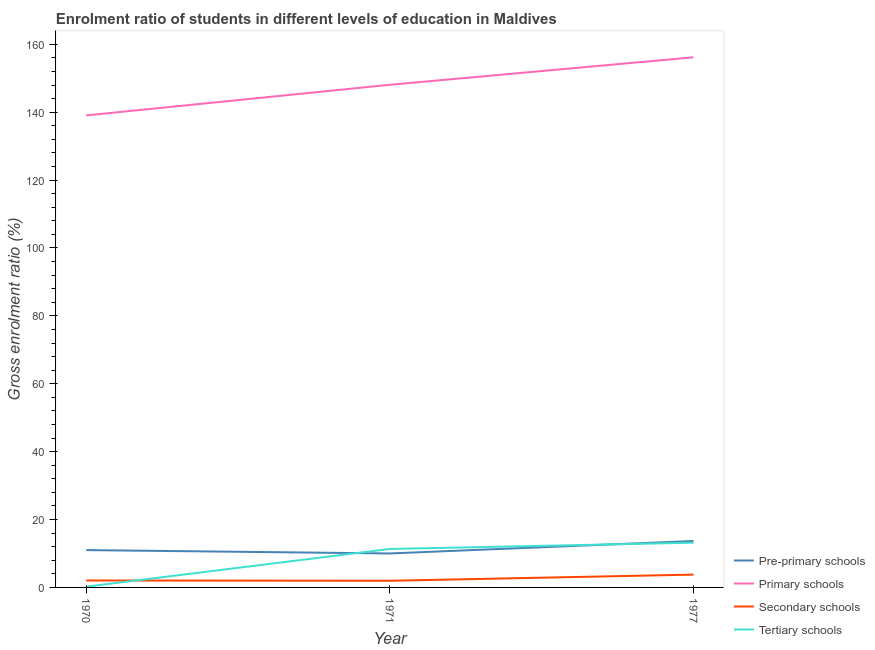Does the line corresponding to gross enrolment ratio in tertiary schools intersect with the line corresponding to gross enrolment ratio in primary schools?
Give a very brief answer. No. What is the gross enrolment ratio in pre-primary schools in 1977?
Your answer should be compact. 13.67. Across all years, what is the maximum gross enrolment ratio in secondary schools?
Offer a terse response. 3.78. Across all years, what is the minimum gross enrolment ratio in secondary schools?
Keep it short and to the point. 1.96. In which year was the gross enrolment ratio in tertiary schools minimum?
Offer a terse response. 1970. What is the total gross enrolment ratio in secondary schools in the graph?
Offer a terse response. 7.78. What is the difference between the gross enrolment ratio in tertiary schools in 1971 and that in 1977?
Give a very brief answer. -1.85. What is the difference between the gross enrolment ratio in secondary schools in 1971 and the gross enrolment ratio in pre-primary schools in 1970?
Make the answer very short. -9.04. What is the average gross enrolment ratio in tertiary schools per year?
Offer a terse response. 8.25. In the year 1970, what is the difference between the gross enrolment ratio in pre-primary schools and gross enrolment ratio in tertiary schools?
Give a very brief answer. 10.78. What is the ratio of the gross enrolment ratio in primary schools in 1971 to that in 1977?
Your answer should be compact. 0.95. Is the gross enrolment ratio in pre-primary schools in 1970 less than that in 1971?
Provide a succinct answer. No. Is the difference between the gross enrolment ratio in primary schools in 1970 and 1977 greater than the difference between the gross enrolment ratio in pre-primary schools in 1970 and 1977?
Your answer should be compact. No. What is the difference between the highest and the second highest gross enrolment ratio in tertiary schools?
Give a very brief answer. 1.85. What is the difference between the highest and the lowest gross enrolment ratio in primary schools?
Keep it short and to the point. 17.12. Is the sum of the gross enrolment ratio in secondary schools in 1970 and 1977 greater than the maximum gross enrolment ratio in pre-primary schools across all years?
Your response must be concise. No. Is it the case that in every year, the sum of the gross enrolment ratio in pre-primary schools and gross enrolment ratio in primary schools is greater than the gross enrolment ratio in secondary schools?
Your answer should be very brief. Yes. Does the gross enrolment ratio in pre-primary schools monotonically increase over the years?
Your response must be concise. No. Is the gross enrolment ratio in secondary schools strictly less than the gross enrolment ratio in tertiary schools over the years?
Ensure brevity in your answer.  No. How many lines are there?
Provide a succinct answer. 4. How many legend labels are there?
Make the answer very short. 4. How are the legend labels stacked?
Your answer should be very brief. Vertical. What is the title of the graph?
Keep it short and to the point. Enrolment ratio of students in different levels of education in Maldives. What is the Gross enrolment ratio (%) of Pre-primary schools in 1970?
Keep it short and to the point. 11. What is the Gross enrolment ratio (%) in Primary schools in 1970?
Your response must be concise. 139.05. What is the Gross enrolment ratio (%) of Secondary schools in 1970?
Keep it short and to the point. 2.05. What is the Gross enrolment ratio (%) of Tertiary schools in 1970?
Make the answer very short. 0.22. What is the Gross enrolment ratio (%) in Pre-primary schools in 1971?
Keep it short and to the point. 10.01. What is the Gross enrolment ratio (%) in Primary schools in 1971?
Your response must be concise. 148.08. What is the Gross enrolment ratio (%) in Secondary schools in 1971?
Give a very brief answer. 1.96. What is the Gross enrolment ratio (%) in Tertiary schools in 1971?
Make the answer very short. 11.34. What is the Gross enrolment ratio (%) in Pre-primary schools in 1977?
Ensure brevity in your answer.  13.67. What is the Gross enrolment ratio (%) in Primary schools in 1977?
Your answer should be compact. 156.17. What is the Gross enrolment ratio (%) of Secondary schools in 1977?
Your answer should be compact. 3.78. What is the Gross enrolment ratio (%) of Tertiary schools in 1977?
Your response must be concise. 13.18. Across all years, what is the maximum Gross enrolment ratio (%) in Pre-primary schools?
Provide a short and direct response. 13.67. Across all years, what is the maximum Gross enrolment ratio (%) in Primary schools?
Your answer should be compact. 156.17. Across all years, what is the maximum Gross enrolment ratio (%) in Secondary schools?
Provide a short and direct response. 3.78. Across all years, what is the maximum Gross enrolment ratio (%) of Tertiary schools?
Provide a succinct answer. 13.18. Across all years, what is the minimum Gross enrolment ratio (%) of Pre-primary schools?
Ensure brevity in your answer.  10.01. Across all years, what is the minimum Gross enrolment ratio (%) of Primary schools?
Offer a very short reply. 139.05. Across all years, what is the minimum Gross enrolment ratio (%) of Secondary schools?
Provide a succinct answer. 1.96. Across all years, what is the minimum Gross enrolment ratio (%) of Tertiary schools?
Provide a short and direct response. 0.22. What is the total Gross enrolment ratio (%) in Pre-primary schools in the graph?
Make the answer very short. 34.68. What is the total Gross enrolment ratio (%) of Primary schools in the graph?
Provide a succinct answer. 443.3. What is the total Gross enrolment ratio (%) in Secondary schools in the graph?
Ensure brevity in your answer.  7.78. What is the total Gross enrolment ratio (%) in Tertiary schools in the graph?
Keep it short and to the point. 24.74. What is the difference between the Gross enrolment ratio (%) of Pre-primary schools in 1970 and that in 1971?
Your answer should be compact. 0.99. What is the difference between the Gross enrolment ratio (%) of Primary schools in 1970 and that in 1971?
Give a very brief answer. -9.02. What is the difference between the Gross enrolment ratio (%) of Secondary schools in 1970 and that in 1971?
Give a very brief answer. 0.09. What is the difference between the Gross enrolment ratio (%) of Tertiary schools in 1970 and that in 1971?
Give a very brief answer. -11.11. What is the difference between the Gross enrolment ratio (%) in Pre-primary schools in 1970 and that in 1977?
Offer a terse response. -2.67. What is the difference between the Gross enrolment ratio (%) in Primary schools in 1970 and that in 1977?
Your response must be concise. -17.12. What is the difference between the Gross enrolment ratio (%) in Secondary schools in 1970 and that in 1977?
Give a very brief answer. -1.73. What is the difference between the Gross enrolment ratio (%) in Tertiary schools in 1970 and that in 1977?
Give a very brief answer. -12.96. What is the difference between the Gross enrolment ratio (%) of Pre-primary schools in 1971 and that in 1977?
Provide a short and direct response. -3.67. What is the difference between the Gross enrolment ratio (%) of Primary schools in 1971 and that in 1977?
Provide a short and direct response. -8.09. What is the difference between the Gross enrolment ratio (%) of Secondary schools in 1971 and that in 1977?
Ensure brevity in your answer.  -1.81. What is the difference between the Gross enrolment ratio (%) of Tertiary schools in 1971 and that in 1977?
Offer a terse response. -1.85. What is the difference between the Gross enrolment ratio (%) in Pre-primary schools in 1970 and the Gross enrolment ratio (%) in Primary schools in 1971?
Offer a terse response. -137.08. What is the difference between the Gross enrolment ratio (%) in Pre-primary schools in 1970 and the Gross enrolment ratio (%) in Secondary schools in 1971?
Keep it short and to the point. 9.04. What is the difference between the Gross enrolment ratio (%) of Pre-primary schools in 1970 and the Gross enrolment ratio (%) of Tertiary schools in 1971?
Keep it short and to the point. -0.34. What is the difference between the Gross enrolment ratio (%) of Primary schools in 1970 and the Gross enrolment ratio (%) of Secondary schools in 1971?
Make the answer very short. 137.09. What is the difference between the Gross enrolment ratio (%) of Primary schools in 1970 and the Gross enrolment ratio (%) of Tertiary schools in 1971?
Your answer should be very brief. 127.72. What is the difference between the Gross enrolment ratio (%) of Secondary schools in 1970 and the Gross enrolment ratio (%) of Tertiary schools in 1971?
Your response must be concise. -9.29. What is the difference between the Gross enrolment ratio (%) of Pre-primary schools in 1970 and the Gross enrolment ratio (%) of Primary schools in 1977?
Give a very brief answer. -145.17. What is the difference between the Gross enrolment ratio (%) of Pre-primary schools in 1970 and the Gross enrolment ratio (%) of Secondary schools in 1977?
Your answer should be very brief. 7.22. What is the difference between the Gross enrolment ratio (%) of Pre-primary schools in 1970 and the Gross enrolment ratio (%) of Tertiary schools in 1977?
Offer a very short reply. -2.18. What is the difference between the Gross enrolment ratio (%) in Primary schools in 1970 and the Gross enrolment ratio (%) in Secondary schools in 1977?
Make the answer very short. 135.28. What is the difference between the Gross enrolment ratio (%) of Primary schools in 1970 and the Gross enrolment ratio (%) of Tertiary schools in 1977?
Provide a succinct answer. 125.87. What is the difference between the Gross enrolment ratio (%) of Secondary schools in 1970 and the Gross enrolment ratio (%) of Tertiary schools in 1977?
Provide a succinct answer. -11.13. What is the difference between the Gross enrolment ratio (%) of Pre-primary schools in 1971 and the Gross enrolment ratio (%) of Primary schools in 1977?
Provide a succinct answer. -146.16. What is the difference between the Gross enrolment ratio (%) of Pre-primary schools in 1971 and the Gross enrolment ratio (%) of Secondary schools in 1977?
Your response must be concise. 6.23. What is the difference between the Gross enrolment ratio (%) in Pre-primary schools in 1971 and the Gross enrolment ratio (%) in Tertiary schools in 1977?
Your answer should be compact. -3.17. What is the difference between the Gross enrolment ratio (%) of Primary schools in 1971 and the Gross enrolment ratio (%) of Secondary schools in 1977?
Offer a terse response. 144.3. What is the difference between the Gross enrolment ratio (%) of Primary schools in 1971 and the Gross enrolment ratio (%) of Tertiary schools in 1977?
Offer a terse response. 134.89. What is the difference between the Gross enrolment ratio (%) of Secondary schools in 1971 and the Gross enrolment ratio (%) of Tertiary schools in 1977?
Offer a very short reply. -11.22. What is the average Gross enrolment ratio (%) of Pre-primary schools per year?
Give a very brief answer. 11.56. What is the average Gross enrolment ratio (%) in Primary schools per year?
Your answer should be very brief. 147.77. What is the average Gross enrolment ratio (%) of Secondary schools per year?
Provide a succinct answer. 2.59. What is the average Gross enrolment ratio (%) in Tertiary schools per year?
Provide a succinct answer. 8.25. In the year 1970, what is the difference between the Gross enrolment ratio (%) of Pre-primary schools and Gross enrolment ratio (%) of Primary schools?
Your answer should be very brief. -128.05. In the year 1970, what is the difference between the Gross enrolment ratio (%) of Pre-primary schools and Gross enrolment ratio (%) of Secondary schools?
Ensure brevity in your answer.  8.95. In the year 1970, what is the difference between the Gross enrolment ratio (%) in Pre-primary schools and Gross enrolment ratio (%) in Tertiary schools?
Make the answer very short. 10.78. In the year 1970, what is the difference between the Gross enrolment ratio (%) of Primary schools and Gross enrolment ratio (%) of Secondary schools?
Provide a short and direct response. 137.01. In the year 1970, what is the difference between the Gross enrolment ratio (%) of Primary schools and Gross enrolment ratio (%) of Tertiary schools?
Keep it short and to the point. 138.83. In the year 1970, what is the difference between the Gross enrolment ratio (%) in Secondary schools and Gross enrolment ratio (%) in Tertiary schools?
Ensure brevity in your answer.  1.83. In the year 1971, what is the difference between the Gross enrolment ratio (%) of Pre-primary schools and Gross enrolment ratio (%) of Primary schools?
Your answer should be compact. -138.07. In the year 1971, what is the difference between the Gross enrolment ratio (%) in Pre-primary schools and Gross enrolment ratio (%) in Secondary schools?
Ensure brevity in your answer.  8.05. In the year 1971, what is the difference between the Gross enrolment ratio (%) of Pre-primary schools and Gross enrolment ratio (%) of Tertiary schools?
Your answer should be compact. -1.33. In the year 1971, what is the difference between the Gross enrolment ratio (%) of Primary schools and Gross enrolment ratio (%) of Secondary schools?
Your answer should be very brief. 146.12. In the year 1971, what is the difference between the Gross enrolment ratio (%) of Primary schools and Gross enrolment ratio (%) of Tertiary schools?
Provide a succinct answer. 136.74. In the year 1971, what is the difference between the Gross enrolment ratio (%) of Secondary schools and Gross enrolment ratio (%) of Tertiary schools?
Offer a terse response. -9.37. In the year 1977, what is the difference between the Gross enrolment ratio (%) of Pre-primary schools and Gross enrolment ratio (%) of Primary schools?
Provide a short and direct response. -142.5. In the year 1977, what is the difference between the Gross enrolment ratio (%) of Pre-primary schools and Gross enrolment ratio (%) of Secondary schools?
Provide a short and direct response. 9.9. In the year 1977, what is the difference between the Gross enrolment ratio (%) in Pre-primary schools and Gross enrolment ratio (%) in Tertiary schools?
Your answer should be very brief. 0.49. In the year 1977, what is the difference between the Gross enrolment ratio (%) of Primary schools and Gross enrolment ratio (%) of Secondary schools?
Give a very brief answer. 152.39. In the year 1977, what is the difference between the Gross enrolment ratio (%) of Primary schools and Gross enrolment ratio (%) of Tertiary schools?
Give a very brief answer. 142.99. In the year 1977, what is the difference between the Gross enrolment ratio (%) in Secondary schools and Gross enrolment ratio (%) in Tertiary schools?
Your response must be concise. -9.41. What is the ratio of the Gross enrolment ratio (%) of Pre-primary schools in 1970 to that in 1971?
Offer a terse response. 1.1. What is the ratio of the Gross enrolment ratio (%) in Primary schools in 1970 to that in 1971?
Give a very brief answer. 0.94. What is the ratio of the Gross enrolment ratio (%) in Secondary schools in 1970 to that in 1971?
Provide a succinct answer. 1.04. What is the ratio of the Gross enrolment ratio (%) of Tertiary schools in 1970 to that in 1971?
Your answer should be very brief. 0.02. What is the ratio of the Gross enrolment ratio (%) in Pre-primary schools in 1970 to that in 1977?
Your response must be concise. 0.8. What is the ratio of the Gross enrolment ratio (%) of Primary schools in 1970 to that in 1977?
Keep it short and to the point. 0.89. What is the ratio of the Gross enrolment ratio (%) of Secondary schools in 1970 to that in 1977?
Your answer should be compact. 0.54. What is the ratio of the Gross enrolment ratio (%) in Tertiary schools in 1970 to that in 1977?
Your answer should be compact. 0.02. What is the ratio of the Gross enrolment ratio (%) of Pre-primary schools in 1971 to that in 1977?
Ensure brevity in your answer.  0.73. What is the ratio of the Gross enrolment ratio (%) in Primary schools in 1971 to that in 1977?
Ensure brevity in your answer.  0.95. What is the ratio of the Gross enrolment ratio (%) of Secondary schools in 1971 to that in 1977?
Provide a succinct answer. 0.52. What is the ratio of the Gross enrolment ratio (%) in Tertiary schools in 1971 to that in 1977?
Make the answer very short. 0.86. What is the difference between the highest and the second highest Gross enrolment ratio (%) in Pre-primary schools?
Ensure brevity in your answer.  2.67. What is the difference between the highest and the second highest Gross enrolment ratio (%) in Primary schools?
Give a very brief answer. 8.09. What is the difference between the highest and the second highest Gross enrolment ratio (%) in Secondary schools?
Offer a very short reply. 1.73. What is the difference between the highest and the second highest Gross enrolment ratio (%) in Tertiary schools?
Make the answer very short. 1.85. What is the difference between the highest and the lowest Gross enrolment ratio (%) in Pre-primary schools?
Give a very brief answer. 3.67. What is the difference between the highest and the lowest Gross enrolment ratio (%) of Primary schools?
Make the answer very short. 17.12. What is the difference between the highest and the lowest Gross enrolment ratio (%) in Secondary schools?
Ensure brevity in your answer.  1.81. What is the difference between the highest and the lowest Gross enrolment ratio (%) in Tertiary schools?
Offer a very short reply. 12.96. 